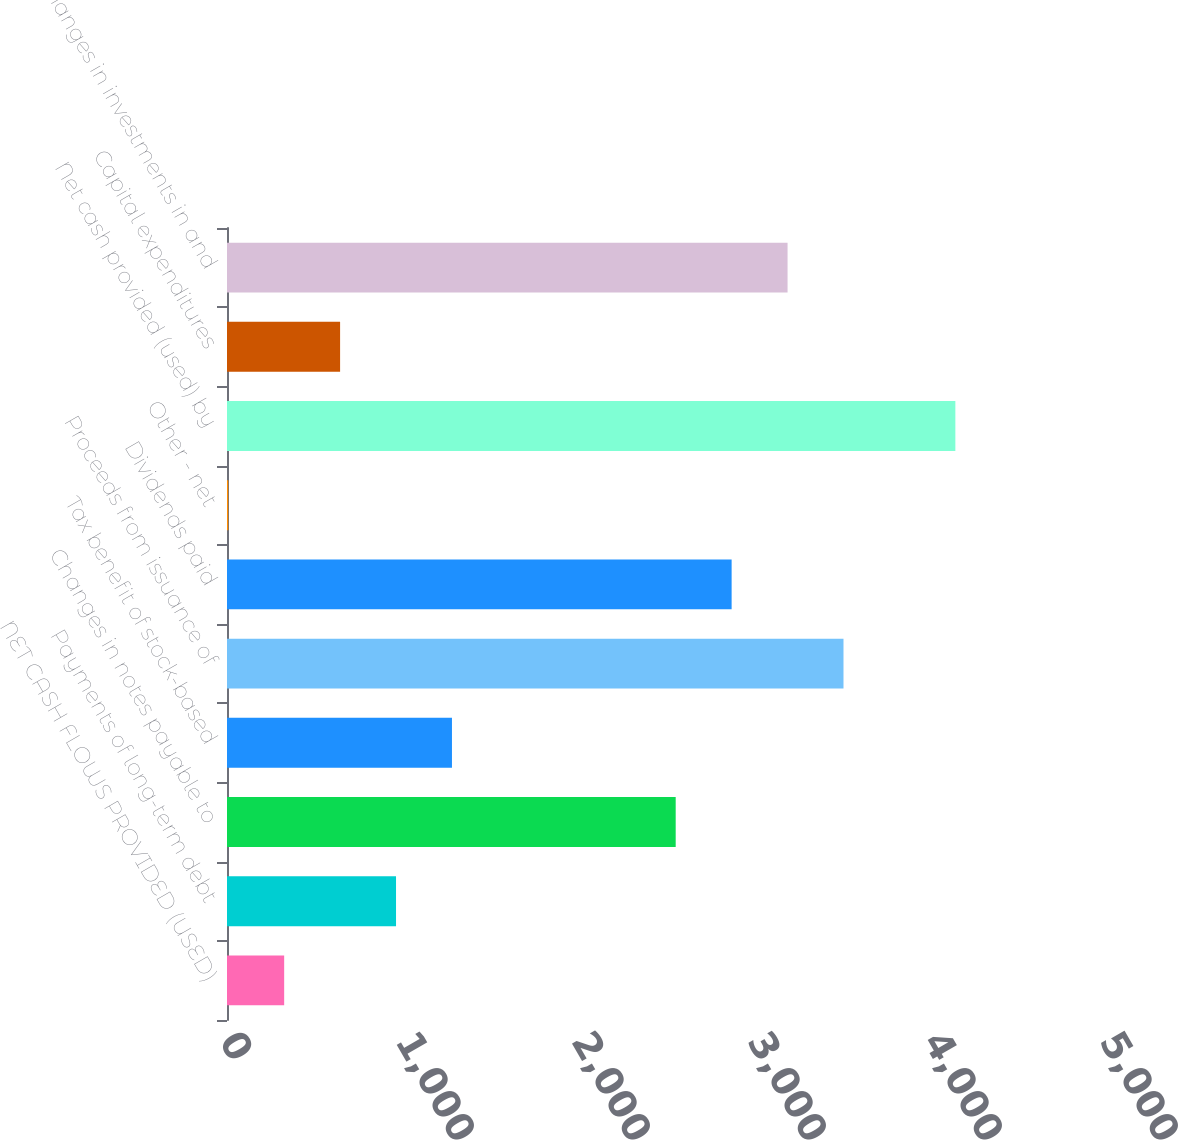Convert chart. <chart><loc_0><loc_0><loc_500><loc_500><bar_chart><fcel>NET CASH FLOWS PROVIDED (USED)<fcel>Payments of long-term debt<fcel>Changes in notes payable to<fcel>Tax benefit of stock-based<fcel>Proceeds from issuance of<fcel>Dividends paid<fcel>Other - net<fcel>Net cash provided (used) by<fcel>Capital expenditures<fcel>Changes in investments in and<nl><fcel>324.8<fcel>960.4<fcel>2549.4<fcel>1278.2<fcel>3502.8<fcel>2867.2<fcel>7<fcel>4138.4<fcel>642.6<fcel>3185<nl></chart> 